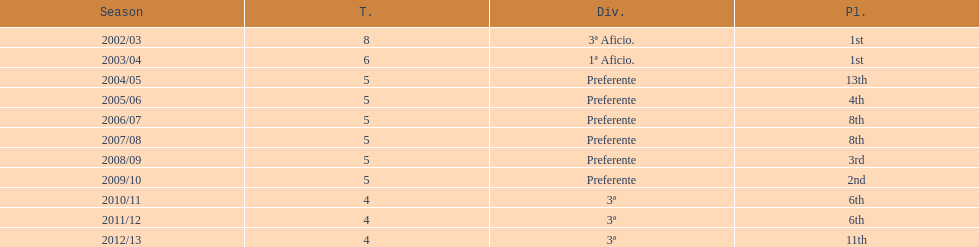How many seasons did internacional de madrid cf play in the preferente division? 6. 